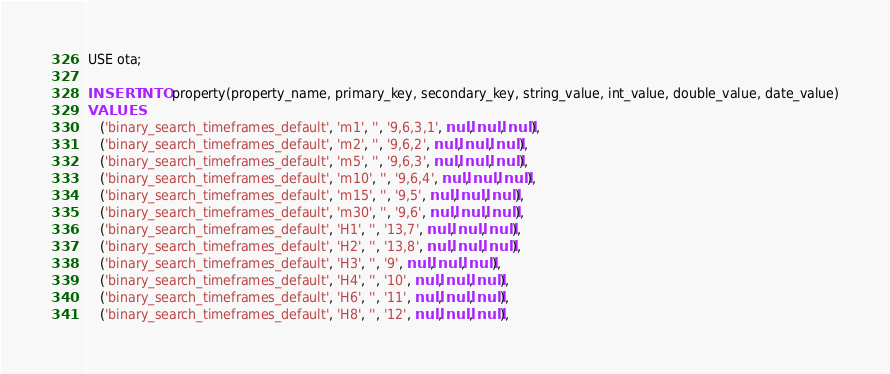Convert code to text. <code><loc_0><loc_0><loc_500><loc_500><_SQL_>USE ota;

INSERT INTO property(property_name, primary_key, secondary_key, string_value, int_value, double_value, date_value)
VALUES
   ('binary_search_timeframes_default', 'm1', '', '9,6,3,1', null, null, null),
   ('binary_search_timeframes_default', 'm2', '', '9,6,2', null, null, null),
   ('binary_search_timeframes_default', 'm5', '', '9,6,3', null, null, null),
   ('binary_search_timeframes_default', 'm10', '', '9,6,4', null, null, null),
   ('binary_search_timeframes_default', 'm15', '', '9,5', null, null, null),
   ('binary_search_timeframes_default', 'm30', '', '9,6', null, null, null),
   ('binary_search_timeframes_default', 'H1', '', '13,7', null, null, null),
   ('binary_search_timeframes_default', 'H2', '', '13,8', null, null, null),
   ('binary_search_timeframes_default', 'H3', '', '9', null, null, null),
   ('binary_search_timeframes_default', 'H4', '', '10', null, null, null),
   ('binary_search_timeframes_default', 'H6', '', '11', null, null, null),
   ('binary_search_timeframes_default', 'H8', '', '12', null, null, null),</code> 